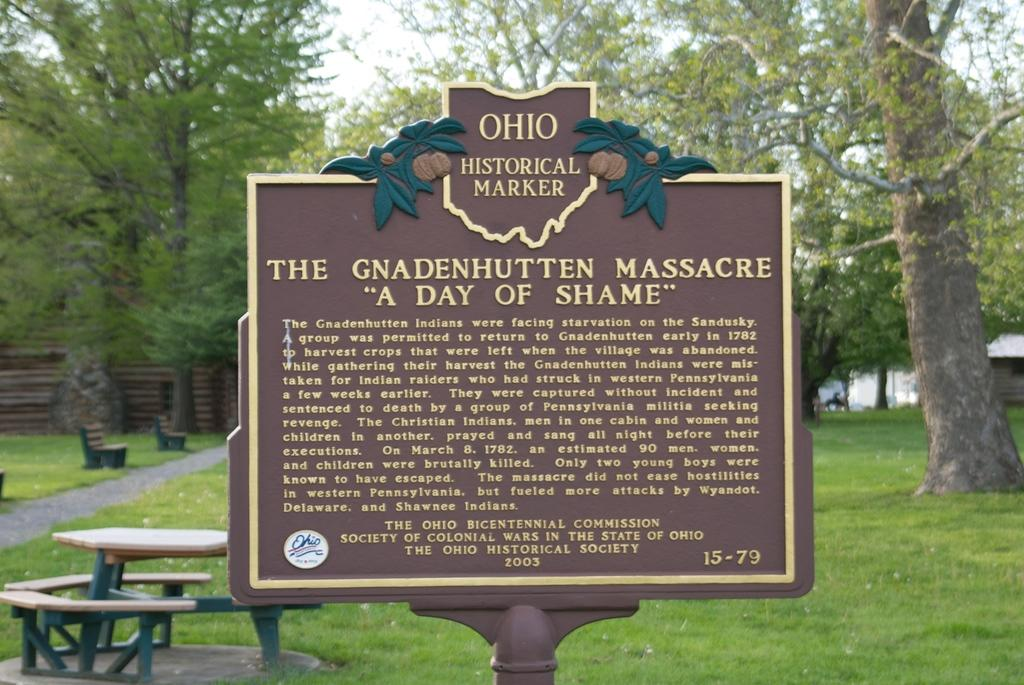What is the main object in the foreground of the image? There is a sign board in the image. What can be seen in the background of the image? There is a table, benches, grassy land, trees, and the sky visible in the background of the image. What type of toy can be seen on the grassy land in the image? There is no toy present on the grassy land in the image. Is there a bone visible in the image? There is no bone visible in the image. 